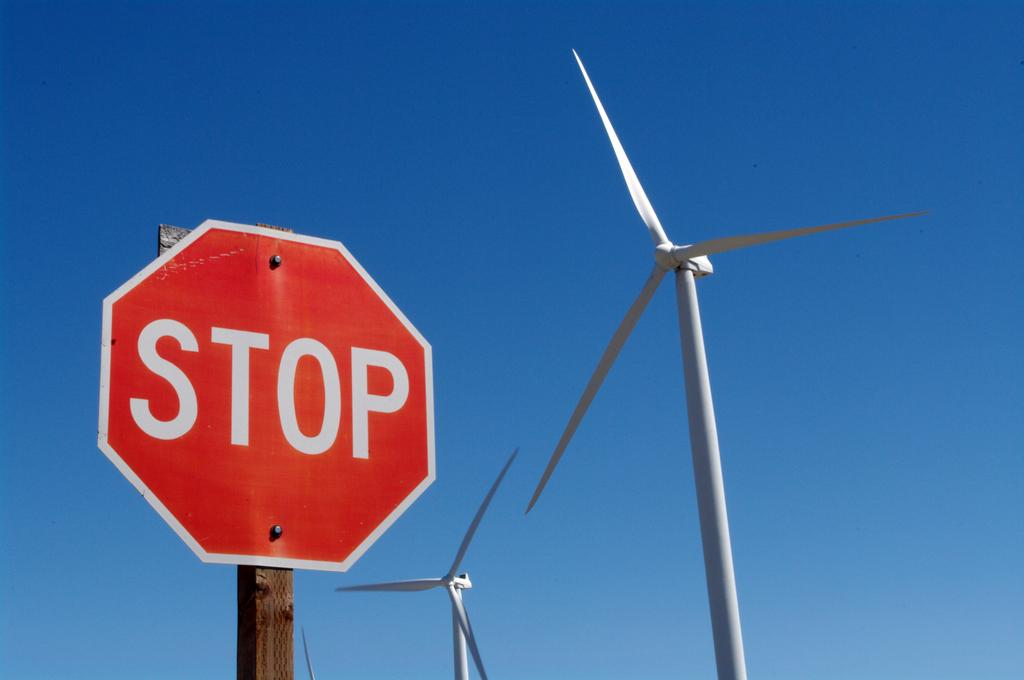<image>
Summarize the visual content of the image. a stop sign that is located outside in the daytime 